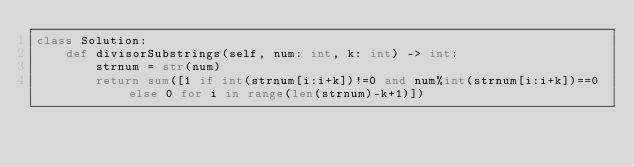<code> <loc_0><loc_0><loc_500><loc_500><_Python_>class Solution:
    def divisorSubstrings(self, num: int, k: int) -> int:
        strnum = str(num)
        return sum([1 if int(strnum[i:i+k])!=0 and num%int(strnum[i:i+k])==0 else 0 for i in range(len(strnum)-k+1)])</code> 